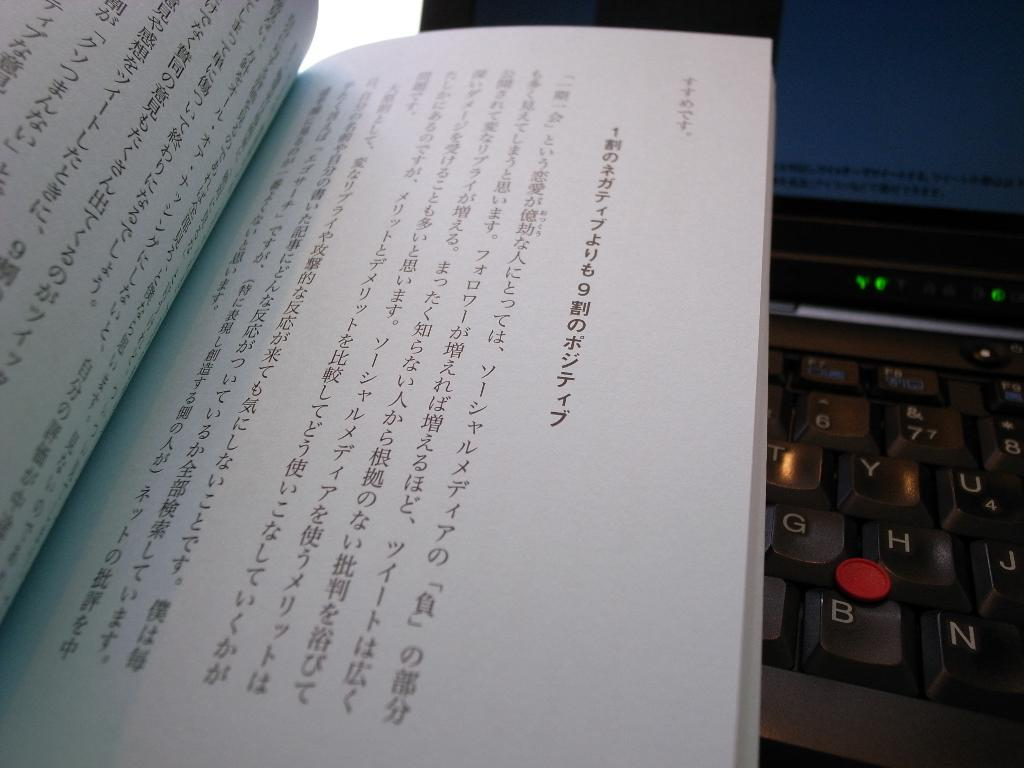<image>
Provide a brief description of the given image. An open book in a foreign language sits next to a keyboard with letters visible including G, H, J, and B. 